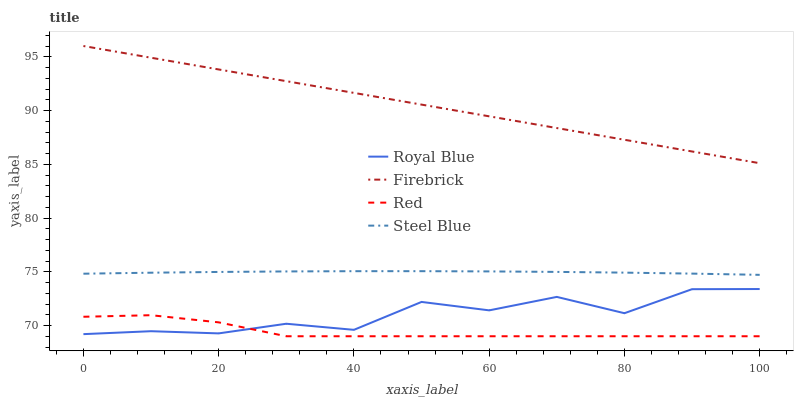Does Red have the minimum area under the curve?
Answer yes or no. Yes. Does Firebrick have the maximum area under the curve?
Answer yes or no. Yes. Does Steel Blue have the minimum area under the curve?
Answer yes or no. No. Does Steel Blue have the maximum area under the curve?
Answer yes or no. No. Is Firebrick the smoothest?
Answer yes or no. Yes. Is Royal Blue the roughest?
Answer yes or no. Yes. Is Steel Blue the smoothest?
Answer yes or no. No. Is Steel Blue the roughest?
Answer yes or no. No. Does Red have the lowest value?
Answer yes or no. Yes. Does Steel Blue have the lowest value?
Answer yes or no. No. Does Firebrick have the highest value?
Answer yes or no. Yes. Does Steel Blue have the highest value?
Answer yes or no. No. Is Royal Blue less than Steel Blue?
Answer yes or no. Yes. Is Firebrick greater than Red?
Answer yes or no. Yes. Does Red intersect Royal Blue?
Answer yes or no. Yes. Is Red less than Royal Blue?
Answer yes or no. No. Is Red greater than Royal Blue?
Answer yes or no. No. Does Royal Blue intersect Steel Blue?
Answer yes or no. No. 